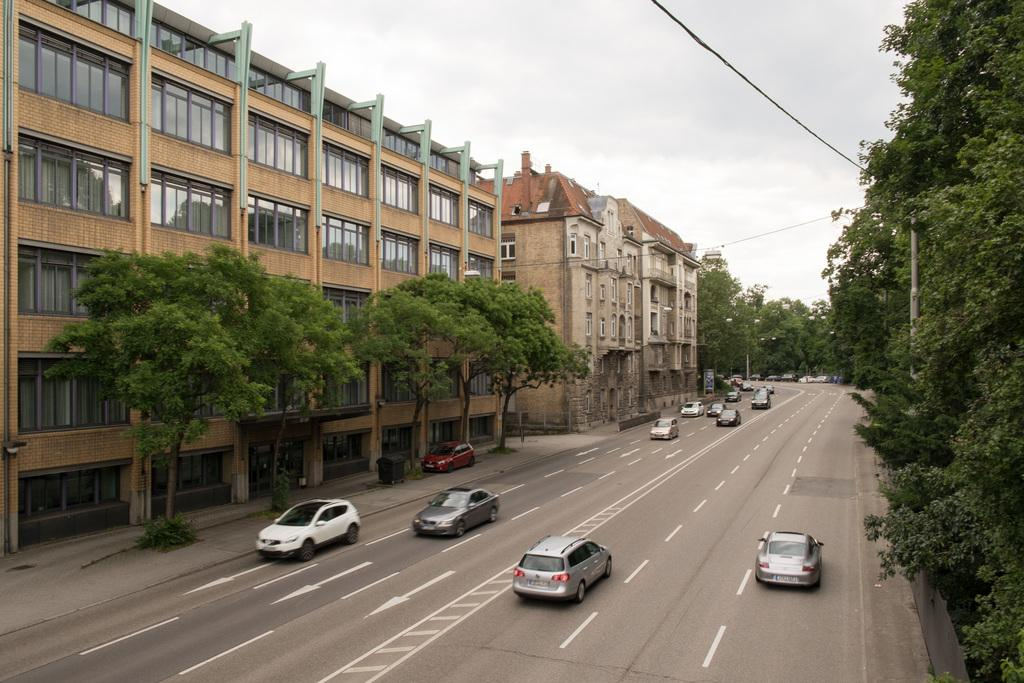What can be seen on the road in the image? There are many cars on the road in the image. What type of vegetation is present on either side of the road? There are trees on either side of the road. What structures can be seen in the background of the image? There are buildings in the background of the image. What part of the natural environment is visible above the road? The sky is visible above the road. What time of day is it in the image, as indicated by the presence of a tree on the sidewalk? There is no tree on the sidewalk in the image, and the time of day cannot be determined from the image alone. 